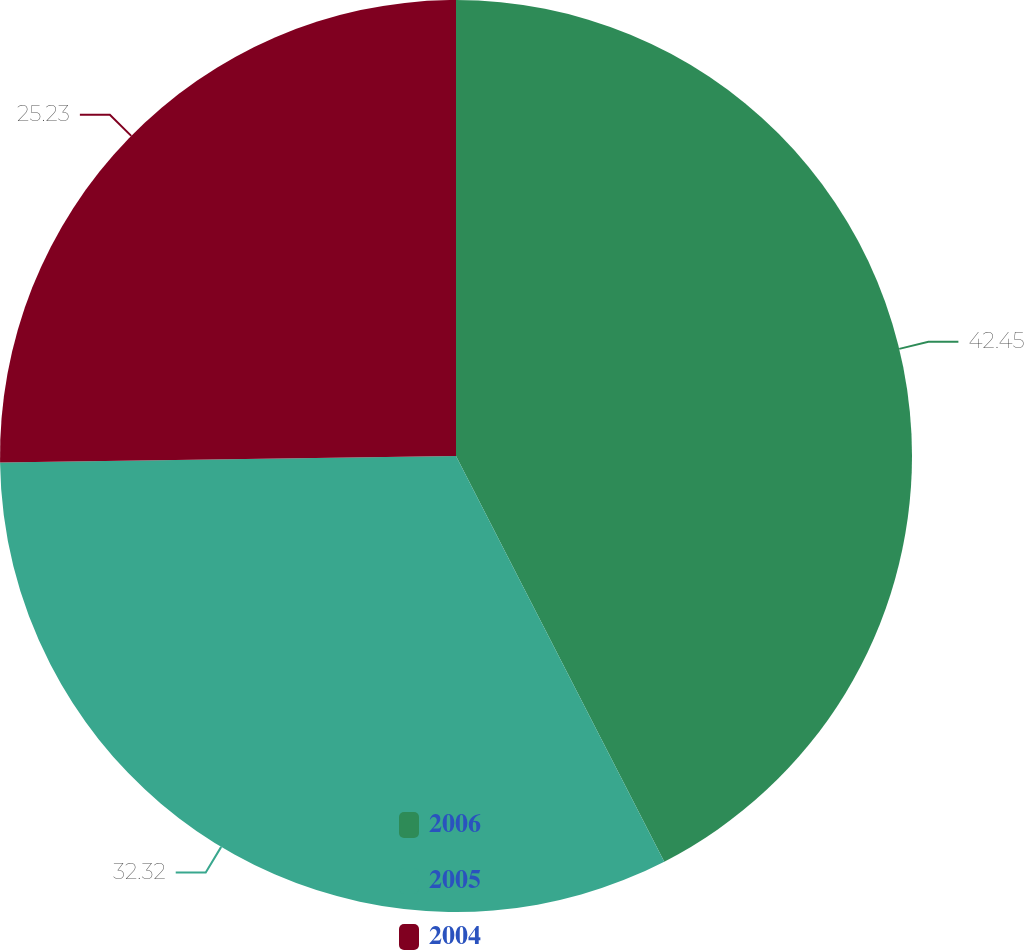<chart> <loc_0><loc_0><loc_500><loc_500><pie_chart><fcel>2006<fcel>2005<fcel>2004<nl><fcel>42.45%<fcel>32.32%<fcel>25.23%<nl></chart> 